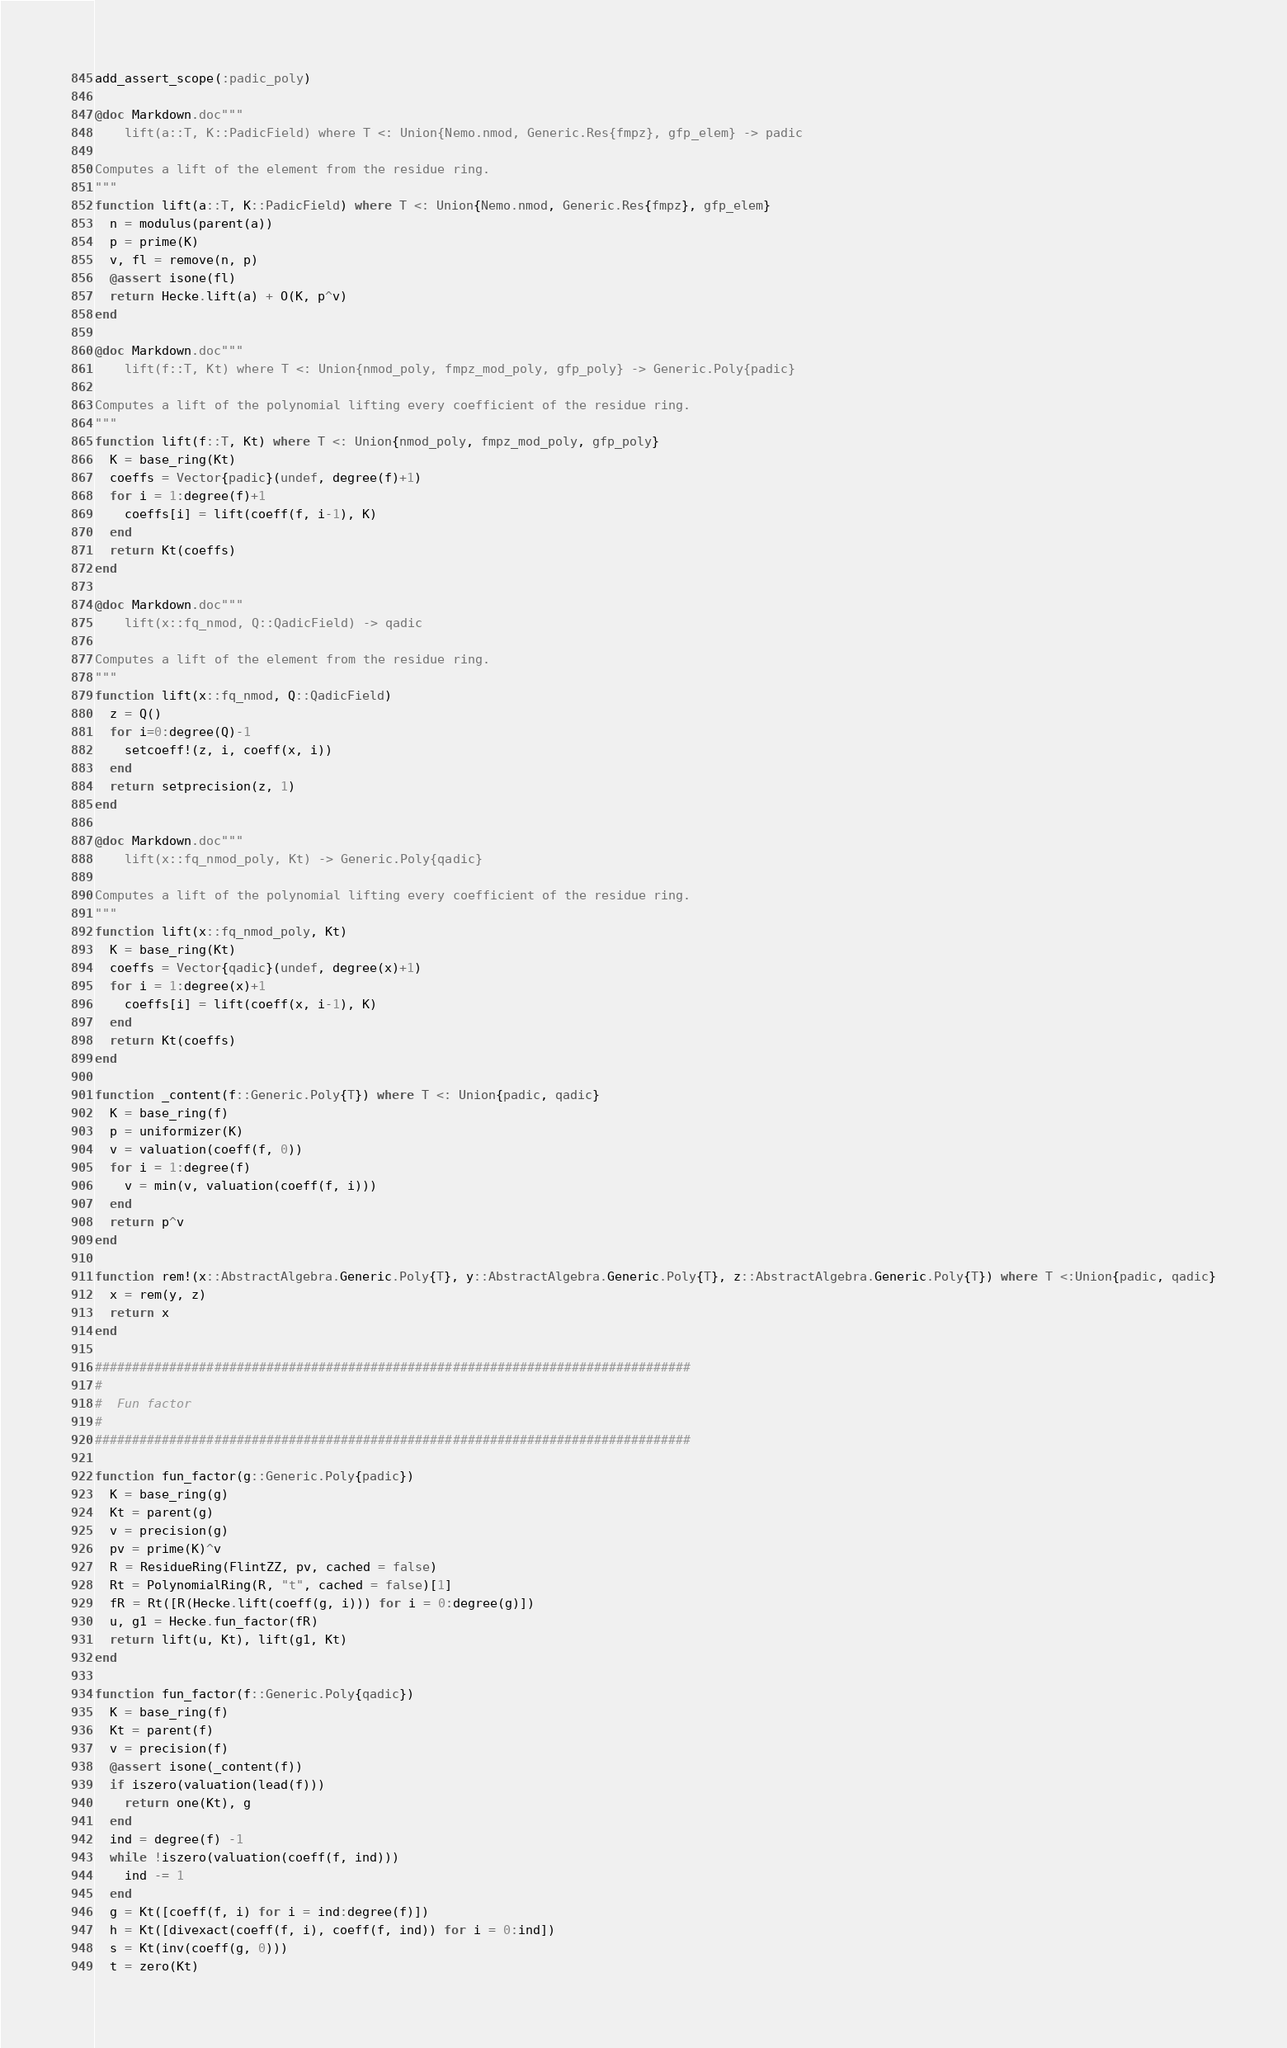Convert code to text. <code><loc_0><loc_0><loc_500><loc_500><_Julia_>
add_assert_scope(:padic_poly)

@doc Markdown.doc"""
    lift(a::T, K::PadicField) where T <: Union{Nemo.nmod, Generic.Res{fmpz}, gfp_elem} -> padic

Computes a lift of the element from the residue ring.
"""
function lift(a::T, K::PadicField) where T <: Union{Nemo.nmod, Generic.Res{fmpz}, gfp_elem} 
  n = modulus(parent(a))
  p = prime(K)
  v, fl = remove(n, p)
  @assert isone(fl)
  return Hecke.lift(a) + O(K, p^v)
end

@doc Markdown.doc"""
    lift(f::T, Kt) where T <: Union{nmod_poly, fmpz_mod_poly, gfp_poly} -> Generic.Poly{padic}

Computes a lift of the polynomial lifting every coefficient of the residue ring.
"""
function lift(f::T, Kt) where T <: Union{nmod_poly, fmpz_mod_poly, gfp_poly}
  K = base_ring(Kt)
  coeffs = Vector{padic}(undef, degree(f)+1)
  for i = 1:degree(f)+1
    coeffs[i] = lift(coeff(f, i-1), K)
  end
  return Kt(coeffs)
end

@doc Markdown.doc"""
    lift(x::fq_nmod, Q::QadicField) -> qadic

Computes a lift of the element from the residue ring.
"""
function lift(x::fq_nmod, Q::QadicField)
  z = Q()
  for i=0:degree(Q)-1
    setcoeff!(z, i, coeff(x, i))
  end
  return setprecision(z, 1)
end

@doc Markdown.doc"""
    lift(x::fq_nmod_poly, Kt) -> Generic.Poly{qadic}

Computes a lift of the polynomial lifting every coefficient of the residue ring.
"""
function lift(x::fq_nmod_poly, Kt)
  K = base_ring(Kt)
  coeffs = Vector{qadic}(undef, degree(x)+1)
  for i = 1:degree(x)+1
    coeffs[i] = lift(coeff(x, i-1), K)
  end
  return Kt(coeffs)
end

function _content(f::Generic.Poly{T}) where T <: Union{padic, qadic}
  K = base_ring(f)
  p = uniformizer(K)
  v = valuation(coeff(f, 0))
  for i = 1:degree(f)
    v = min(v, valuation(coeff(f, i)))
  end
  return p^v
end

function rem!(x::AbstractAlgebra.Generic.Poly{T}, y::AbstractAlgebra.Generic.Poly{T}, z::AbstractAlgebra.Generic.Poly{T}) where T <:Union{padic, qadic}
  x = rem(y, z)
  return x
end

################################################################################
#
#  Fun factor
#
################################################################################

function fun_factor(g::Generic.Poly{padic})
  K = base_ring(g)
  Kt = parent(g)
  v = precision(g)
  pv = prime(K)^v
  R = ResidueRing(FlintZZ, pv, cached = false)
  Rt = PolynomialRing(R, "t", cached = false)[1]
  fR = Rt([R(Hecke.lift(coeff(g, i))) for i = 0:degree(g)])
  u, g1 = Hecke.fun_factor(fR)
  return lift(u, Kt), lift(g1, Kt)
end

function fun_factor(f::Generic.Poly{qadic})
  K = base_ring(f)
  Kt = parent(f)
  v = precision(f)
  @assert isone(_content(f))
  if iszero(valuation(lead(f)))
    return one(Kt), g
  end
  ind = degree(f) -1
  while !iszero(valuation(coeff(f, ind)))
    ind -= 1
  end
  g = Kt([coeff(f, i) for i = ind:degree(f)])
  h = Kt([divexact(coeff(f, i), coeff(f, ind)) for i = 0:ind])
  s = Kt(inv(coeff(g, 0)))
  t = zero(Kt)</code> 